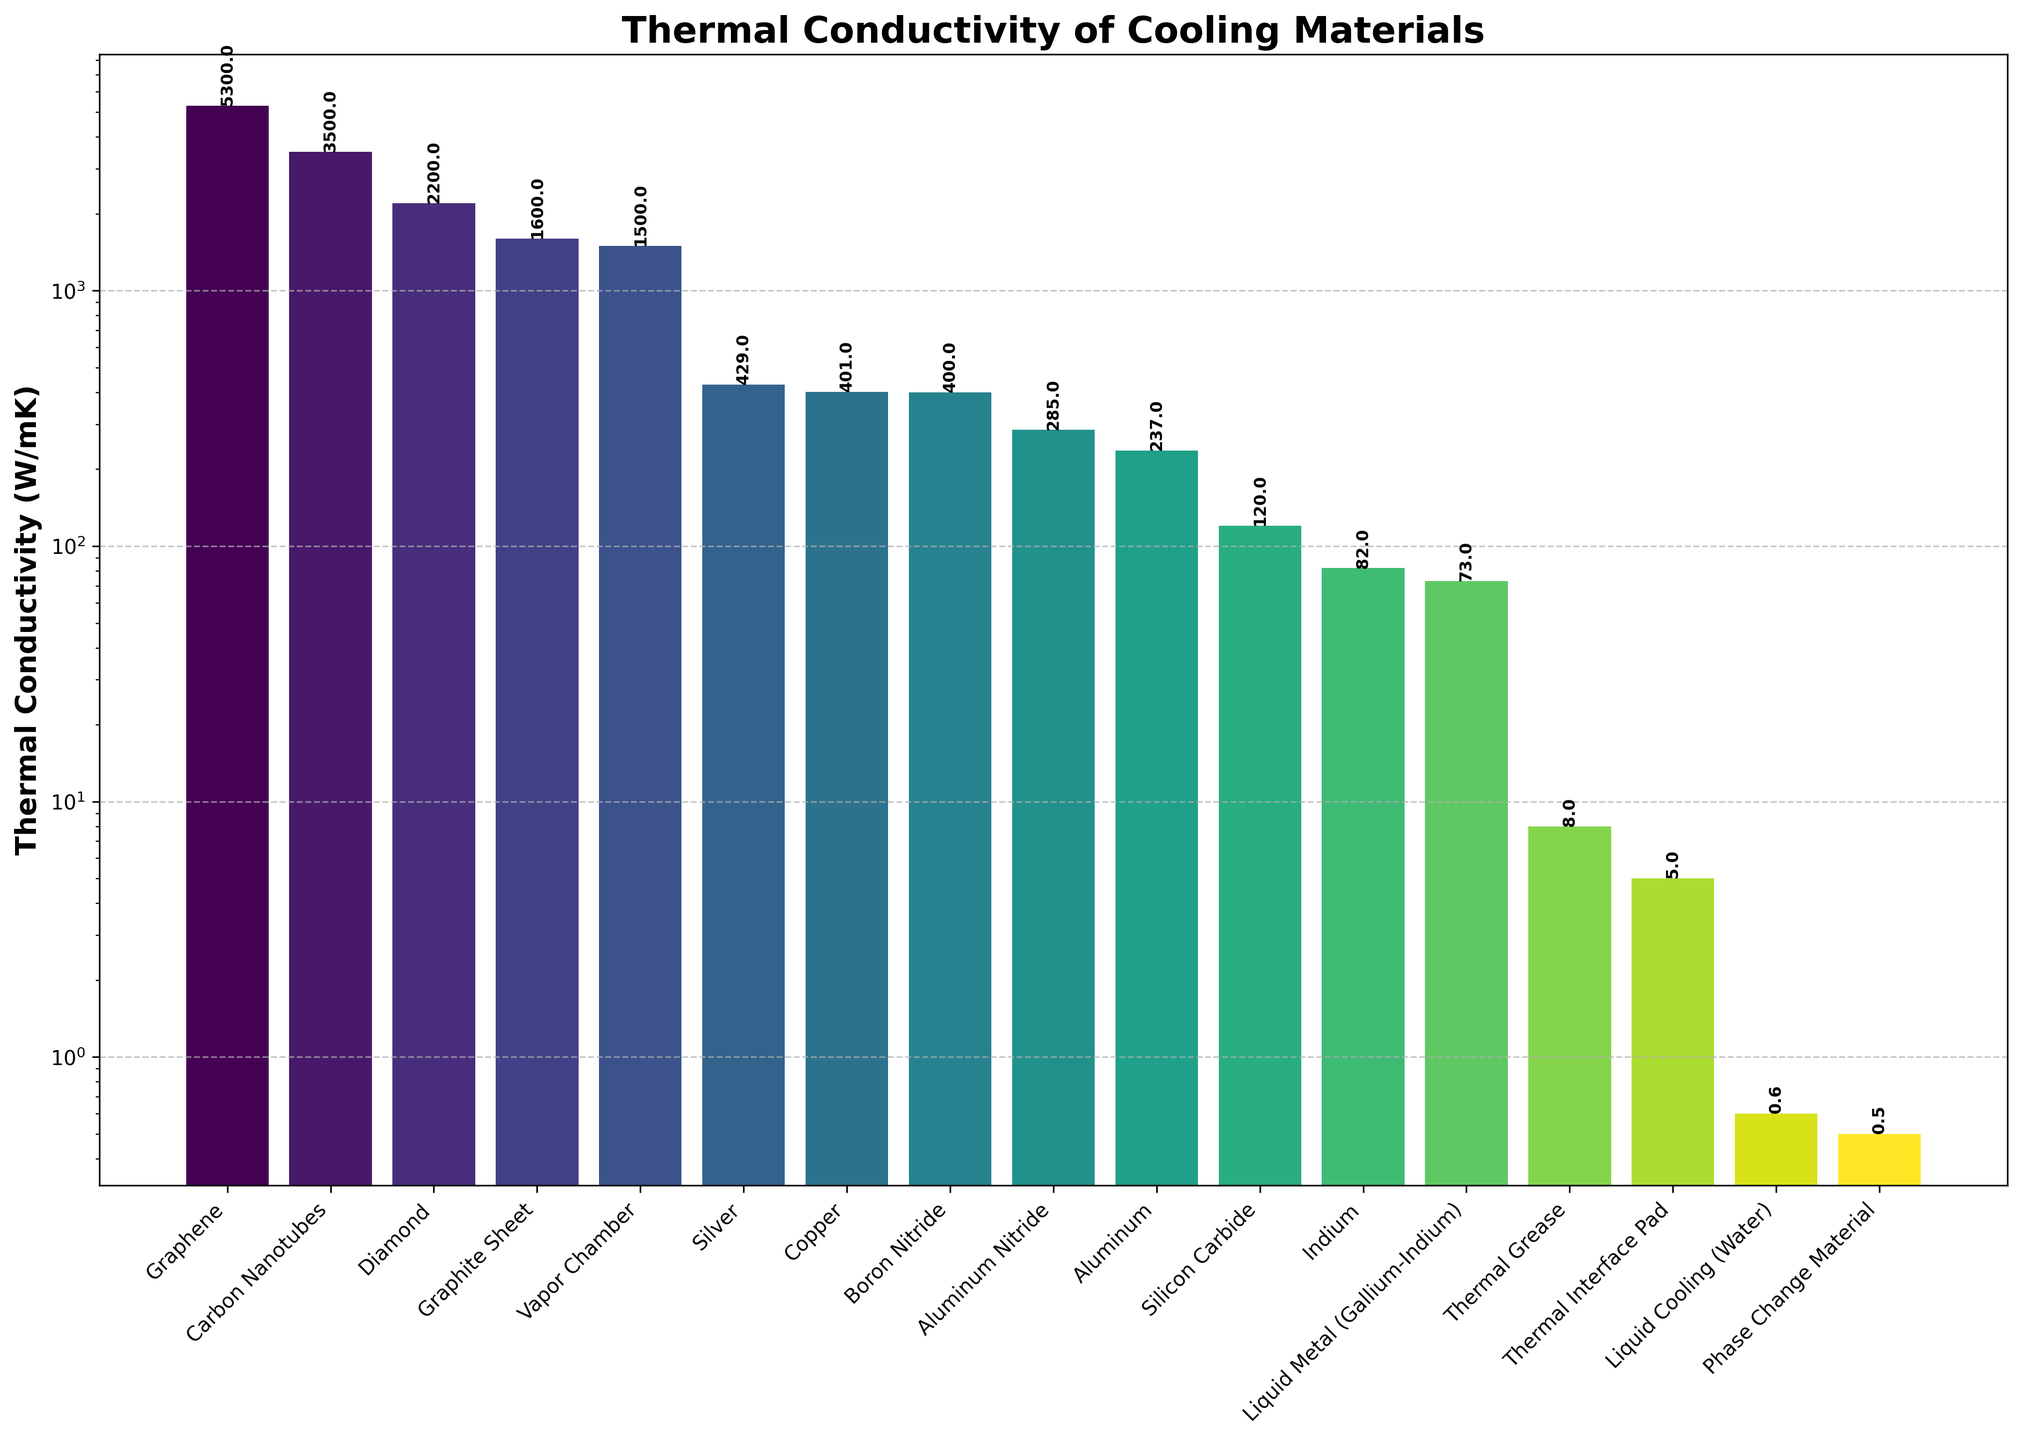What material has the highest thermal conductivity? The material with the highest thermal conductivity will be the tallest bar in the bar plot, so by observing the figure, Graphene is the material with the highest thermal conductivity.
Answer: Graphene How much higher is Diamond's thermal conductivity compared to Copper's? Find the height of the bar representing Diamond and the height of the bar representing Copper. Subtract the thermal conductivity of Copper from Diamond's. Diamond has a thermal conductivity of 2200 W/mK and Copper has 401 W/mK. The difference is 2200 - 401.
Answer: 1799 W/mK What is the thermal conductivity of the material with the shortest bar? The shortest bar represents the material with the lowest thermal conductivity. From the plot, Phase Change Material has the shortest bar.
Answer: 0.5 W/mK Which visual attribute distinguishes Carbon Nanotubes from Boron Nitride in the bar plot? One way to distinguish the materials visually is by comparing their bar heights. Carbon Nanotubes' bar is higher than Boron Nitride's.
Answer: Bar height What are the median and mean of the top five materials with the highest thermal conductivities? Identify the top five materials by their bar heights: Graphene, Carbon Nanotubes, Diamond, Graphite Sheet, Vapor Chamber. Calculate the median and mean of thermal conductivities (5300, 3500, 2200, 1600, 1500). The median is the middle value when sorted, and the mean is the sum divided by the number of values: (5300 + 3500 + 2200 + 1600 + 1500) / 5.
Answer: Median: 2200 W/mK, Mean: 2820 W/mK Which two materials have thermal conductivities closest to each other? Analyze the bar lengths; the bars for Aluminum (237 W/mK) and Aluminum Nitride (285 W/mK) are next to each other and their values are closest with a difference of only 48 W/mK.
Answer: Aluminum and Aluminum Nitride How many of the materials have a thermal conductivity lower than 100 W/mK? Count the bars that fall below 100 W/mK in height. Materials: Thermal Grease (8), Indium (82), Liquid Metal (Gallium-Indium) (73), Phase Change Material (0.5), Thermal Interface Pad (5), Liquid Cooling (Water) (0.6).
Answer: 6 Between Graphite Sheet and Vapor Chamber, which has a higher thermal conductivity and by how much? Compare the heights of the two bars. Graphite Sheet has 1600 W/mK, while Vapor Chamber has 1500 W/mK. The difference is 1600 - 1500.
Answer: Graphite Sheet, 100 W/mK What is the total thermal conductivity of the materials with the three highest conductivities? Add the thermal conductivities of Graphene (5300 W/mK), Carbon Nanotubes (3500 W/mK), and Diamond (2200 W/mK). The total is 5300 + 3500 + 2200.
Answer: 11000 W/mK Which material's bar is approximately in the middle of the plot visually, and what is its thermal conductivity? The middle bar visually corresponds to Boron Nitride since there are several bars on either side of it in the plot. Boron Nitride's thermal conductivity is represented.
Answer: Boron Nitride, 400 W/mK 